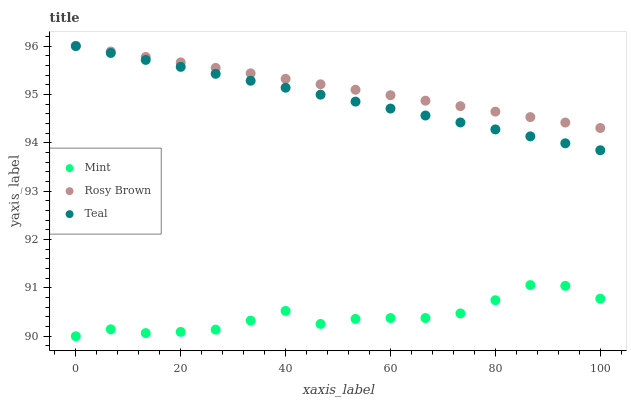Does Mint have the minimum area under the curve?
Answer yes or no. Yes. Does Rosy Brown have the maximum area under the curve?
Answer yes or no. Yes. Does Teal have the minimum area under the curve?
Answer yes or no. No. Does Teal have the maximum area under the curve?
Answer yes or no. No. Is Teal the smoothest?
Answer yes or no. Yes. Is Mint the roughest?
Answer yes or no. Yes. Is Mint the smoothest?
Answer yes or no. No. Is Teal the roughest?
Answer yes or no. No. Does Mint have the lowest value?
Answer yes or no. Yes. Does Teal have the lowest value?
Answer yes or no. No. Does Teal have the highest value?
Answer yes or no. Yes. Does Mint have the highest value?
Answer yes or no. No. Is Mint less than Rosy Brown?
Answer yes or no. Yes. Is Rosy Brown greater than Mint?
Answer yes or no. Yes. Does Teal intersect Rosy Brown?
Answer yes or no. Yes. Is Teal less than Rosy Brown?
Answer yes or no. No. Is Teal greater than Rosy Brown?
Answer yes or no. No. Does Mint intersect Rosy Brown?
Answer yes or no. No. 